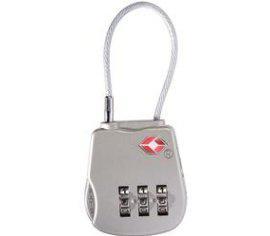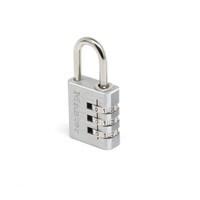The first image is the image on the left, the second image is the image on the right. Analyze the images presented: Is the assertion "Of two locks, one is all metal with sliding number belts on the side, while the other has the number belts in a different position and a white cord lock loop." valid? Answer yes or no. Yes. The first image is the image on the left, the second image is the image on the right. Assess this claim about the two images: "The lock in the image on the right is silver metal.". Correct or not? Answer yes or no. Yes. 